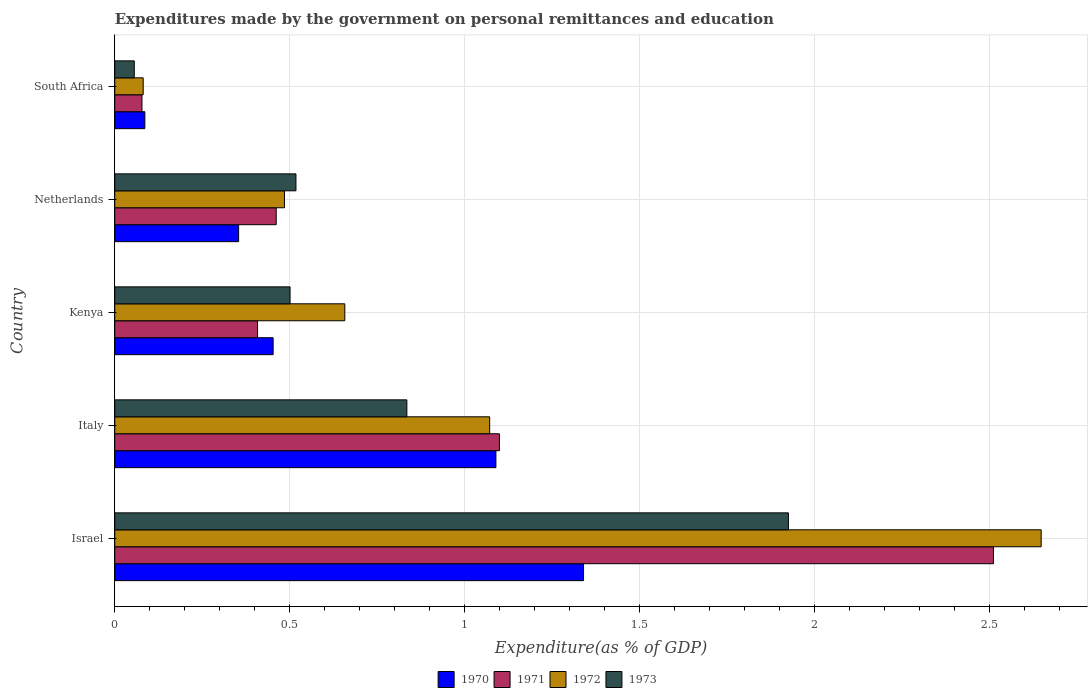How many groups of bars are there?
Your answer should be very brief. 5. Are the number of bars on each tick of the Y-axis equal?
Your answer should be very brief. Yes. How many bars are there on the 4th tick from the top?
Keep it short and to the point. 4. How many bars are there on the 4th tick from the bottom?
Your answer should be compact. 4. What is the label of the 5th group of bars from the top?
Keep it short and to the point. Israel. What is the expenditures made by the government on personal remittances and education in 1973 in Israel?
Ensure brevity in your answer.  1.93. Across all countries, what is the maximum expenditures made by the government on personal remittances and education in 1970?
Your answer should be very brief. 1.34. Across all countries, what is the minimum expenditures made by the government on personal remittances and education in 1973?
Your response must be concise. 0.06. In which country was the expenditures made by the government on personal remittances and education in 1972 minimum?
Provide a short and direct response. South Africa. What is the total expenditures made by the government on personal remittances and education in 1972 in the graph?
Ensure brevity in your answer.  4.94. What is the difference between the expenditures made by the government on personal remittances and education in 1970 in Israel and that in Netherlands?
Give a very brief answer. 0.99. What is the difference between the expenditures made by the government on personal remittances and education in 1970 in Italy and the expenditures made by the government on personal remittances and education in 1973 in Netherlands?
Provide a succinct answer. 0.57. What is the average expenditures made by the government on personal remittances and education in 1971 per country?
Give a very brief answer. 0.91. What is the difference between the expenditures made by the government on personal remittances and education in 1972 and expenditures made by the government on personal remittances and education in 1973 in Israel?
Provide a succinct answer. 0.72. In how many countries, is the expenditures made by the government on personal remittances and education in 1972 greater than 2.3 %?
Offer a very short reply. 1. What is the ratio of the expenditures made by the government on personal remittances and education in 1970 in Italy to that in Netherlands?
Give a very brief answer. 3.08. Is the difference between the expenditures made by the government on personal remittances and education in 1972 in Kenya and South Africa greater than the difference between the expenditures made by the government on personal remittances and education in 1973 in Kenya and South Africa?
Keep it short and to the point. Yes. What is the difference between the highest and the second highest expenditures made by the government on personal remittances and education in 1972?
Give a very brief answer. 1.58. What is the difference between the highest and the lowest expenditures made by the government on personal remittances and education in 1971?
Your response must be concise. 2.43. Is the sum of the expenditures made by the government on personal remittances and education in 1970 in Kenya and South Africa greater than the maximum expenditures made by the government on personal remittances and education in 1972 across all countries?
Ensure brevity in your answer.  No. Is it the case that in every country, the sum of the expenditures made by the government on personal remittances and education in 1972 and expenditures made by the government on personal remittances and education in 1973 is greater than the sum of expenditures made by the government on personal remittances and education in 1971 and expenditures made by the government on personal remittances and education in 1970?
Offer a terse response. No. What does the 3rd bar from the top in Netherlands represents?
Make the answer very short. 1971. What does the 3rd bar from the bottom in South Africa represents?
Give a very brief answer. 1972. Is it the case that in every country, the sum of the expenditures made by the government on personal remittances and education in 1971 and expenditures made by the government on personal remittances and education in 1973 is greater than the expenditures made by the government on personal remittances and education in 1970?
Offer a very short reply. Yes. What is the title of the graph?
Offer a very short reply. Expenditures made by the government on personal remittances and education. What is the label or title of the X-axis?
Provide a succinct answer. Expenditure(as % of GDP). What is the Expenditure(as % of GDP) of 1970 in Israel?
Your response must be concise. 1.34. What is the Expenditure(as % of GDP) of 1971 in Israel?
Keep it short and to the point. 2.51. What is the Expenditure(as % of GDP) of 1972 in Israel?
Provide a short and direct response. 2.65. What is the Expenditure(as % of GDP) in 1973 in Israel?
Offer a terse response. 1.93. What is the Expenditure(as % of GDP) in 1970 in Italy?
Provide a short and direct response. 1.09. What is the Expenditure(as % of GDP) of 1971 in Italy?
Offer a very short reply. 1.1. What is the Expenditure(as % of GDP) in 1972 in Italy?
Your answer should be very brief. 1.07. What is the Expenditure(as % of GDP) in 1973 in Italy?
Provide a short and direct response. 0.84. What is the Expenditure(as % of GDP) of 1970 in Kenya?
Offer a very short reply. 0.45. What is the Expenditure(as % of GDP) of 1971 in Kenya?
Provide a short and direct response. 0.41. What is the Expenditure(as % of GDP) of 1972 in Kenya?
Offer a terse response. 0.66. What is the Expenditure(as % of GDP) of 1973 in Kenya?
Offer a terse response. 0.5. What is the Expenditure(as % of GDP) of 1970 in Netherlands?
Give a very brief answer. 0.35. What is the Expenditure(as % of GDP) of 1971 in Netherlands?
Give a very brief answer. 0.46. What is the Expenditure(as % of GDP) of 1972 in Netherlands?
Offer a very short reply. 0.49. What is the Expenditure(as % of GDP) of 1973 in Netherlands?
Keep it short and to the point. 0.52. What is the Expenditure(as % of GDP) in 1970 in South Africa?
Keep it short and to the point. 0.09. What is the Expenditure(as % of GDP) in 1971 in South Africa?
Ensure brevity in your answer.  0.08. What is the Expenditure(as % of GDP) in 1972 in South Africa?
Offer a terse response. 0.08. What is the Expenditure(as % of GDP) in 1973 in South Africa?
Provide a succinct answer. 0.06. Across all countries, what is the maximum Expenditure(as % of GDP) of 1970?
Ensure brevity in your answer.  1.34. Across all countries, what is the maximum Expenditure(as % of GDP) of 1971?
Keep it short and to the point. 2.51. Across all countries, what is the maximum Expenditure(as % of GDP) in 1972?
Offer a terse response. 2.65. Across all countries, what is the maximum Expenditure(as % of GDP) of 1973?
Offer a very short reply. 1.93. Across all countries, what is the minimum Expenditure(as % of GDP) of 1970?
Offer a very short reply. 0.09. Across all countries, what is the minimum Expenditure(as % of GDP) in 1971?
Give a very brief answer. 0.08. Across all countries, what is the minimum Expenditure(as % of GDP) in 1972?
Your response must be concise. 0.08. Across all countries, what is the minimum Expenditure(as % of GDP) of 1973?
Provide a short and direct response. 0.06. What is the total Expenditure(as % of GDP) in 1970 in the graph?
Offer a very short reply. 3.32. What is the total Expenditure(as % of GDP) in 1971 in the graph?
Provide a short and direct response. 4.56. What is the total Expenditure(as % of GDP) in 1972 in the graph?
Keep it short and to the point. 4.94. What is the total Expenditure(as % of GDP) of 1973 in the graph?
Offer a very short reply. 3.84. What is the difference between the Expenditure(as % of GDP) of 1970 in Israel and that in Italy?
Your answer should be compact. 0.25. What is the difference between the Expenditure(as % of GDP) of 1971 in Israel and that in Italy?
Your response must be concise. 1.41. What is the difference between the Expenditure(as % of GDP) of 1972 in Israel and that in Italy?
Make the answer very short. 1.58. What is the difference between the Expenditure(as % of GDP) of 1973 in Israel and that in Italy?
Provide a succinct answer. 1.09. What is the difference between the Expenditure(as % of GDP) of 1970 in Israel and that in Kenya?
Your answer should be compact. 0.89. What is the difference between the Expenditure(as % of GDP) of 1971 in Israel and that in Kenya?
Provide a short and direct response. 2.1. What is the difference between the Expenditure(as % of GDP) of 1972 in Israel and that in Kenya?
Your answer should be compact. 1.99. What is the difference between the Expenditure(as % of GDP) in 1973 in Israel and that in Kenya?
Make the answer very short. 1.42. What is the difference between the Expenditure(as % of GDP) of 1970 in Israel and that in Netherlands?
Offer a terse response. 0.99. What is the difference between the Expenditure(as % of GDP) in 1971 in Israel and that in Netherlands?
Your answer should be very brief. 2.05. What is the difference between the Expenditure(as % of GDP) in 1972 in Israel and that in Netherlands?
Your answer should be very brief. 2.16. What is the difference between the Expenditure(as % of GDP) of 1973 in Israel and that in Netherlands?
Keep it short and to the point. 1.41. What is the difference between the Expenditure(as % of GDP) of 1970 in Israel and that in South Africa?
Your response must be concise. 1.25. What is the difference between the Expenditure(as % of GDP) of 1971 in Israel and that in South Africa?
Your answer should be very brief. 2.43. What is the difference between the Expenditure(as % of GDP) of 1972 in Israel and that in South Africa?
Keep it short and to the point. 2.57. What is the difference between the Expenditure(as % of GDP) in 1973 in Israel and that in South Africa?
Provide a short and direct response. 1.87. What is the difference between the Expenditure(as % of GDP) of 1970 in Italy and that in Kenya?
Keep it short and to the point. 0.64. What is the difference between the Expenditure(as % of GDP) in 1971 in Italy and that in Kenya?
Your answer should be compact. 0.69. What is the difference between the Expenditure(as % of GDP) of 1972 in Italy and that in Kenya?
Provide a short and direct response. 0.41. What is the difference between the Expenditure(as % of GDP) of 1973 in Italy and that in Kenya?
Provide a succinct answer. 0.33. What is the difference between the Expenditure(as % of GDP) of 1970 in Italy and that in Netherlands?
Offer a very short reply. 0.74. What is the difference between the Expenditure(as % of GDP) of 1971 in Italy and that in Netherlands?
Give a very brief answer. 0.64. What is the difference between the Expenditure(as % of GDP) in 1972 in Italy and that in Netherlands?
Provide a succinct answer. 0.59. What is the difference between the Expenditure(as % of GDP) in 1973 in Italy and that in Netherlands?
Your answer should be very brief. 0.32. What is the difference between the Expenditure(as % of GDP) in 1970 in Italy and that in South Africa?
Provide a short and direct response. 1. What is the difference between the Expenditure(as % of GDP) in 1971 in Italy and that in South Africa?
Make the answer very short. 1.02. What is the difference between the Expenditure(as % of GDP) of 1972 in Italy and that in South Africa?
Keep it short and to the point. 0.99. What is the difference between the Expenditure(as % of GDP) in 1973 in Italy and that in South Africa?
Keep it short and to the point. 0.78. What is the difference between the Expenditure(as % of GDP) of 1970 in Kenya and that in Netherlands?
Your answer should be compact. 0.1. What is the difference between the Expenditure(as % of GDP) in 1971 in Kenya and that in Netherlands?
Give a very brief answer. -0.05. What is the difference between the Expenditure(as % of GDP) in 1972 in Kenya and that in Netherlands?
Your answer should be compact. 0.17. What is the difference between the Expenditure(as % of GDP) in 1973 in Kenya and that in Netherlands?
Keep it short and to the point. -0.02. What is the difference between the Expenditure(as % of GDP) of 1970 in Kenya and that in South Africa?
Offer a terse response. 0.37. What is the difference between the Expenditure(as % of GDP) of 1971 in Kenya and that in South Africa?
Give a very brief answer. 0.33. What is the difference between the Expenditure(as % of GDP) of 1972 in Kenya and that in South Africa?
Offer a terse response. 0.58. What is the difference between the Expenditure(as % of GDP) of 1973 in Kenya and that in South Africa?
Provide a succinct answer. 0.45. What is the difference between the Expenditure(as % of GDP) of 1970 in Netherlands and that in South Africa?
Provide a short and direct response. 0.27. What is the difference between the Expenditure(as % of GDP) of 1971 in Netherlands and that in South Africa?
Your answer should be compact. 0.38. What is the difference between the Expenditure(as % of GDP) in 1972 in Netherlands and that in South Africa?
Ensure brevity in your answer.  0.4. What is the difference between the Expenditure(as % of GDP) of 1973 in Netherlands and that in South Africa?
Your answer should be very brief. 0.46. What is the difference between the Expenditure(as % of GDP) in 1970 in Israel and the Expenditure(as % of GDP) in 1971 in Italy?
Keep it short and to the point. 0.24. What is the difference between the Expenditure(as % of GDP) in 1970 in Israel and the Expenditure(as % of GDP) in 1972 in Italy?
Your answer should be compact. 0.27. What is the difference between the Expenditure(as % of GDP) in 1970 in Israel and the Expenditure(as % of GDP) in 1973 in Italy?
Provide a short and direct response. 0.51. What is the difference between the Expenditure(as % of GDP) in 1971 in Israel and the Expenditure(as % of GDP) in 1972 in Italy?
Offer a very short reply. 1.44. What is the difference between the Expenditure(as % of GDP) in 1971 in Israel and the Expenditure(as % of GDP) in 1973 in Italy?
Keep it short and to the point. 1.68. What is the difference between the Expenditure(as % of GDP) in 1972 in Israel and the Expenditure(as % of GDP) in 1973 in Italy?
Ensure brevity in your answer.  1.81. What is the difference between the Expenditure(as % of GDP) in 1970 in Israel and the Expenditure(as % of GDP) in 1971 in Kenya?
Provide a short and direct response. 0.93. What is the difference between the Expenditure(as % of GDP) of 1970 in Israel and the Expenditure(as % of GDP) of 1972 in Kenya?
Ensure brevity in your answer.  0.68. What is the difference between the Expenditure(as % of GDP) of 1970 in Israel and the Expenditure(as % of GDP) of 1973 in Kenya?
Give a very brief answer. 0.84. What is the difference between the Expenditure(as % of GDP) of 1971 in Israel and the Expenditure(as % of GDP) of 1972 in Kenya?
Offer a very short reply. 1.85. What is the difference between the Expenditure(as % of GDP) of 1971 in Israel and the Expenditure(as % of GDP) of 1973 in Kenya?
Provide a succinct answer. 2.01. What is the difference between the Expenditure(as % of GDP) in 1972 in Israel and the Expenditure(as % of GDP) in 1973 in Kenya?
Give a very brief answer. 2.15. What is the difference between the Expenditure(as % of GDP) in 1970 in Israel and the Expenditure(as % of GDP) in 1971 in Netherlands?
Offer a very short reply. 0.88. What is the difference between the Expenditure(as % of GDP) of 1970 in Israel and the Expenditure(as % of GDP) of 1972 in Netherlands?
Give a very brief answer. 0.85. What is the difference between the Expenditure(as % of GDP) in 1970 in Israel and the Expenditure(as % of GDP) in 1973 in Netherlands?
Your answer should be very brief. 0.82. What is the difference between the Expenditure(as % of GDP) in 1971 in Israel and the Expenditure(as % of GDP) in 1972 in Netherlands?
Provide a succinct answer. 2.03. What is the difference between the Expenditure(as % of GDP) in 1971 in Israel and the Expenditure(as % of GDP) in 1973 in Netherlands?
Provide a short and direct response. 1.99. What is the difference between the Expenditure(as % of GDP) in 1972 in Israel and the Expenditure(as % of GDP) in 1973 in Netherlands?
Give a very brief answer. 2.13. What is the difference between the Expenditure(as % of GDP) in 1970 in Israel and the Expenditure(as % of GDP) in 1971 in South Africa?
Your answer should be compact. 1.26. What is the difference between the Expenditure(as % of GDP) of 1970 in Israel and the Expenditure(as % of GDP) of 1972 in South Africa?
Offer a very short reply. 1.26. What is the difference between the Expenditure(as % of GDP) in 1970 in Israel and the Expenditure(as % of GDP) in 1973 in South Africa?
Ensure brevity in your answer.  1.28. What is the difference between the Expenditure(as % of GDP) of 1971 in Israel and the Expenditure(as % of GDP) of 1972 in South Africa?
Give a very brief answer. 2.43. What is the difference between the Expenditure(as % of GDP) in 1971 in Israel and the Expenditure(as % of GDP) in 1973 in South Africa?
Your response must be concise. 2.46. What is the difference between the Expenditure(as % of GDP) in 1972 in Israel and the Expenditure(as % of GDP) in 1973 in South Africa?
Give a very brief answer. 2.59. What is the difference between the Expenditure(as % of GDP) of 1970 in Italy and the Expenditure(as % of GDP) of 1971 in Kenya?
Your response must be concise. 0.68. What is the difference between the Expenditure(as % of GDP) in 1970 in Italy and the Expenditure(as % of GDP) in 1972 in Kenya?
Offer a very short reply. 0.43. What is the difference between the Expenditure(as % of GDP) of 1970 in Italy and the Expenditure(as % of GDP) of 1973 in Kenya?
Give a very brief answer. 0.59. What is the difference between the Expenditure(as % of GDP) in 1971 in Italy and the Expenditure(as % of GDP) in 1972 in Kenya?
Offer a terse response. 0.44. What is the difference between the Expenditure(as % of GDP) of 1971 in Italy and the Expenditure(as % of GDP) of 1973 in Kenya?
Ensure brevity in your answer.  0.6. What is the difference between the Expenditure(as % of GDP) in 1972 in Italy and the Expenditure(as % of GDP) in 1973 in Kenya?
Ensure brevity in your answer.  0.57. What is the difference between the Expenditure(as % of GDP) in 1970 in Italy and the Expenditure(as % of GDP) in 1971 in Netherlands?
Give a very brief answer. 0.63. What is the difference between the Expenditure(as % of GDP) of 1970 in Italy and the Expenditure(as % of GDP) of 1972 in Netherlands?
Offer a terse response. 0.6. What is the difference between the Expenditure(as % of GDP) of 1970 in Italy and the Expenditure(as % of GDP) of 1973 in Netherlands?
Give a very brief answer. 0.57. What is the difference between the Expenditure(as % of GDP) of 1971 in Italy and the Expenditure(as % of GDP) of 1972 in Netherlands?
Keep it short and to the point. 0.61. What is the difference between the Expenditure(as % of GDP) in 1971 in Italy and the Expenditure(as % of GDP) in 1973 in Netherlands?
Your response must be concise. 0.58. What is the difference between the Expenditure(as % of GDP) in 1972 in Italy and the Expenditure(as % of GDP) in 1973 in Netherlands?
Offer a very short reply. 0.55. What is the difference between the Expenditure(as % of GDP) of 1970 in Italy and the Expenditure(as % of GDP) of 1971 in South Africa?
Give a very brief answer. 1.01. What is the difference between the Expenditure(as % of GDP) in 1970 in Italy and the Expenditure(as % of GDP) in 1972 in South Africa?
Ensure brevity in your answer.  1.01. What is the difference between the Expenditure(as % of GDP) of 1970 in Italy and the Expenditure(as % of GDP) of 1973 in South Africa?
Make the answer very short. 1.03. What is the difference between the Expenditure(as % of GDP) of 1971 in Italy and the Expenditure(as % of GDP) of 1972 in South Africa?
Your answer should be very brief. 1.02. What is the difference between the Expenditure(as % of GDP) in 1971 in Italy and the Expenditure(as % of GDP) in 1973 in South Africa?
Keep it short and to the point. 1.04. What is the difference between the Expenditure(as % of GDP) of 1970 in Kenya and the Expenditure(as % of GDP) of 1971 in Netherlands?
Your response must be concise. -0.01. What is the difference between the Expenditure(as % of GDP) of 1970 in Kenya and the Expenditure(as % of GDP) of 1972 in Netherlands?
Provide a succinct answer. -0.03. What is the difference between the Expenditure(as % of GDP) of 1970 in Kenya and the Expenditure(as % of GDP) of 1973 in Netherlands?
Keep it short and to the point. -0.07. What is the difference between the Expenditure(as % of GDP) of 1971 in Kenya and the Expenditure(as % of GDP) of 1972 in Netherlands?
Offer a very short reply. -0.08. What is the difference between the Expenditure(as % of GDP) of 1971 in Kenya and the Expenditure(as % of GDP) of 1973 in Netherlands?
Offer a very short reply. -0.11. What is the difference between the Expenditure(as % of GDP) in 1972 in Kenya and the Expenditure(as % of GDP) in 1973 in Netherlands?
Provide a succinct answer. 0.14. What is the difference between the Expenditure(as % of GDP) of 1970 in Kenya and the Expenditure(as % of GDP) of 1972 in South Africa?
Offer a terse response. 0.37. What is the difference between the Expenditure(as % of GDP) in 1970 in Kenya and the Expenditure(as % of GDP) in 1973 in South Africa?
Provide a short and direct response. 0.4. What is the difference between the Expenditure(as % of GDP) in 1971 in Kenya and the Expenditure(as % of GDP) in 1972 in South Africa?
Ensure brevity in your answer.  0.33. What is the difference between the Expenditure(as % of GDP) of 1971 in Kenya and the Expenditure(as % of GDP) of 1973 in South Africa?
Your answer should be very brief. 0.35. What is the difference between the Expenditure(as % of GDP) of 1972 in Kenya and the Expenditure(as % of GDP) of 1973 in South Africa?
Make the answer very short. 0.6. What is the difference between the Expenditure(as % of GDP) in 1970 in Netherlands and the Expenditure(as % of GDP) in 1971 in South Africa?
Provide a short and direct response. 0.28. What is the difference between the Expenditure(as % of GDP) in 1970 in Netherlands and the Expenditure(as % of GDP) in 1972 in South Africa?
Your answer should be very brief. 0.27. What is the difference between the Expenditure(as % of GDP) of 1970 in Netherlands and the Expenditure(as % of GDP) of 1973 in South Africa?
Ensure brevity in your answer.  0.3. What is the difference between the Expenditure(as % of GDP) in 1971 in Netherlands and the Expenditure(as % of GDP) in 1972 in South Africa?
Keep it short and to the point. 0.38. What is the difference between the Expenditure(as % of GDP) in 1971 in Netherlands and the Expenditure(as % of GDP) in 1973 in South Africa?
Offer a terse response. 0.41. What is the difference between the Expenditure(as % of GDP) in 1972 in Netherlands and the Expenditure(as % of GDP) in 1973 in South Africa?
Your answer should be compact. 0.43. What is the average Expenditure(as % of GDP) in 1970 per country?
Your answer should be compact. 0.66. What is the average Expenditure(as % of GDP) in 1971 per country?
Your answer should be compact. 0.91. What is the average Expenditure(as % of GDP) in 1972 per country?
Provide a succinct answer. 0.99. What is the average Expenditure(as % of GDP) in 1973 per country?
Your answer should be compact. 0.77. What is the difference between the Expenditure(as % of GDP) of 1970 and Expenditure(as % of GDP) of 1971 in Israel?
Provide a short and direct response. -1.17. What is the difference between the Expenditure(as % of GDP) in 1970 and Expenditure(as % of GDP) in 1972 in Israel?
Ensure brevity in your answer.  -1.31. What is the difference between the Expenditure(as % of GDP) in 1970 and Expenditure(as % of GDP) in 1973 in Israel?
Provide a short and direct response. -0.59. What is the difference between the Expenditure(as % of GDP) in 1971 and Expenditure(as % of GDP) in 1972 in Israel?
Your answer should be very brief. -0.14. What is the difference between the Expenditure(as % of GDP) in 1971 and Expenditure(as % of GDP) in 1973 in Israel?
Offer a terse response. 0.59. What is the difference between the Expenditure(as % of GDP) in 1972 and Expenditure(as % of GDP) in 1973 in Israel?
Provide a succinct answer. 0.72. What is the difference between the Expenditure(as % of GDP) of 1970 and Expenditure(as % of GDP) of 1971 in Italy?
Ensure brevity in your answer.  -0.01. What is the difference between the Expenditure(as % of GDP) of 1970 and Expenditure(as % of GDP) of 1972 in Italy?
Give a very brief answer. 0.02. What is the difference between the Expenditure(as % of GDP) in 1970 and Expenditure(as % of GDP) in 1973 in Italy?
Make the answer very short. 0.25. What is the difference between the Expenditure(as % of GDP) of 1971 and Expenditure(as % of GDP) of 1972 in Italy?
Provide a succinct answer. 0.03. What is the difference between the Expenditure(as % of GDP) of 1971 and Expenditure(as % of GDP) of 1973 in Italy?
Provide a short and direct response. 0.26. What is the difference between the Expenditure(as % of GDP) in 1972 and Expenditure(as % of GDP) in 1973 in Italy?
Offer a very short reply. 0.24. What is the difference between the Expenditure(as % of GDP) of 1970 and Expenditure(as % of GDP) of 1971 in Kenya?
Give a very brief answer. 0.04. What is the difference between the Expenditure(as % of GDP) of 1970 and Expenditure(as % of GDP) of 1972 in Kenya?
Provide a short and direct response. -0.2. What is the difference between the Expenditure(as % of GDP) of 1970 and Expenditure(as % of GDP) of 1973 in Kenya?
Your answer should be compact. -0.05. What is the difference between the Expenditure(as % of GDP) of 1971 and Expenditure(as % of GDP) of 1972 in Kenya?
Your answer should be compact. -0.25. What is the difference between the Expenditure(as % of GDP) in 1971 and Expenditure(as % of GDP) in 1973 in Kenya?
Give a very brief answer. -0.09. What is the difference between the Expenditure(as % of GDP) of 1972 and Expenditure(as % of GDP) of 1973 in Kenya?
Provide a succinct answer. 0.16. What is the difference between the Expenditure(as % of GDP) in 1970 and Expenditure(as % of GDP) in 1971 in Netherlands?
Provide a short and direct response. -0.11. What is the difference between the Expenditure(as % of GDP) in 1970 and Expenditure(as % of GDP) in 1972 in Netherlands?
Offer a very short reply. -0.13. What is the difference between the Expenditure(as % of GDP) of 1970 and Expenditure(as % of GDP) of 1973 in Netherlands?
Your response must be concise. -0.16. What is the difference between the Expenditure(as % of GDP) in 1971 and Expenditure(as % of GDP) in 1972 in Netherlands?
Your answer should be very brief. -0.02. What is the difference between the Expenditure(as % of GDP) in 1971 and Expenditure(as % of GDP) in 1973 in Netherlands?
Ensure brevity in your answer.  -0.06. What is the difference between the Expenditure(as % of GDP) in 1972 and Expenditure(as % of GDP) in 1973 in Netherlands?
Make the answer very short. -0.03. What is the difference between the Expenditure(as % of GDP) in 1970 and Expenditure(as % of GDP) in 1971 in South Africa?
Ensure brevity in your answer.  0.01. What is the difference between the Expenditure(as % of GDP) of 1970 and Expenditure(as % of GDP) of 1972 in South Africa?
Provide a short and direct response. 0. What is the difference between the Expenditure(as % of GDP) of 1970 and Expenditure(as % of GDP) of 1973 in South Africa?
Provide a succinct answer. 0.03. What is the difference between the Expenditure(as % of GDP) of 1971 and Expenditure(as % of GDP) of 1972 in South Africa?
Your response must be concise. -0. What is the difference between the Expenditure(as % of GDP) in 1971 and Expenditure(as % of GDP) in 1973 in South Africa?
Offer a very short reply. 0.02. What is the difference between the Expenditure(as % of GDP) in 1972 and Expenditure(as % of GDP) in 1973 in South Africa?
Provide a succinct answer. 0.03. What is the ratio of the Expenditure(as % of GDP) in 1970 in Israel to that in Italy?
Provide a short and direct response. 1.23. What is the ratio of the Expenditure(as % of GDP) of 1971 in Israel to that in Italy?
Your answer should be very brief. 2.28. What is the ratio of the Expenditure(as % of GDP) in 1972 in Israel to that in Italy?
Offer a very short reply. 2.47. What is the ratio of the Expenditure(as % of GDP) of 1973 in Israel to that in Italy?
Give a very brief answer. 2.31. What is the ratio of the Expenditure(as % of GDP) in 1970 in Israel to that in Kenya?
Your response must be concise. 2.96. What is the ratio of the Expenditure(as % of GDP) in 1971 in Israel to that in Kenya?
Your answer should be very brief. 6.15. What is the ratio of the Expenditure(as % of GDP) in 1972 in Israel to that in Kenya?
Keep it short and to the point. 4.03. What is the ratio of the Expenditure(as % of GDP) of 1973 in Israel to that in Kenya?
Your response must be concise. 3.84. What is the ratio of the Expenditure(as % of GDP) of 1970 in Israel to that in Netherlands?
Give a very brief answer. 3.78. What is the ratio of the Expenditure(as % of GDP) of 1971 in Israel to that in Netherlands?
Ensure brevity in your answer.  5.44. What is the ratio of the Expenditure(as % of GDP) of 1972 in Israel to that in Netherlands?
Provide a short and direct response. 5.46. What is the ratio of the Expenditure(as % of GDP) in 1973 in Israel to that in Netherlands?
Keep it short and to the point. 3.72. What is the ratio of the Expenditure(as % of GDP) in 1970 in Israel to that in South Africa?
Keep it short and to the point. 15.58. What is the ratio of the Expenditure(as % of GDP) in 1971 in Israel to that in South Africa?
Ensure brevity in your answer.  32.29. What is the ratio of the Expenditure(as % of GDP) of 1972 in Israel to that in South Africa?
Provide a short and direct response. 32.58. What is the ratio of the Expenditure(as % of GDP) in 1973 in Israel to that in South Africa?
Provide a short and direct response. 34.5. What is the ratio of the Expenditure(as % of GDP) in 1970 in Italy to that in Kenya?
Your response must be concise. 2.41. What is the ratio of the Expenditure(as % of GDP) in 1971 in Italy to that in Kenya?
Keep it short and to the point. 2.69. What is the ratio of the Expenditure(as % of GDP) of 1972 in Italy to that in Kenya?
Give a very brief answer. 1.63. What is the ratio of the Expenditure(as % of GDP) of 1973 in Italy to that in Kenya?
Your answer should be compact. 1.67. What is the ratio of the Expenditure(as % of GDP) in 1970 in Italy to that in Netherlands?
Provide a succinct answer. 3.08. What is the ratio of the Expenditure(as % of GDP) of 1971 in Italy to that in Netherlands?
Provide a succinct answer. 2.38. What is the ratio of the Expenditure(as % of GDP) of 1972 in Italy to that in Netherlands?
Your answer should be compact. 2.21. What is the ratio of the Expenditure(as % of GDP) of 1973 in Italy to that in Netherlands?
Your answer should be very brief. 1.61. What is the ratio of the Expenditure(as % of GDP) of 1970 in Italy to that in South Africa?
Provide a short and direct response. 12.67. What is the ratio of the Expenditure(as % of GDP) of 1971 in Italy to that in South Africa?
Keep it short and to the point. 14.13. What is the ratio of the Expenditure(as % of GDP) of 1972 in Italy to that in South Africa?
Your answer should be very brief. 13.18. What is the ratio of the Expenditure(as % of GDP) of 1973 in Italy to that in South Africa?
Offer a terse response. 14.96. What is the ratio of the Expenditure(as % of GDP) in 1970 in Kenya to that in Netherlands?
Provide a short and direct response. 1.28. What is the ratio of the Expenditure(as % of GDP) of 1971 in Kenya to that in Netherlands?
Provide a short and direct response. 0.88. What is the ratio of the Expenditure(as % of GDP) in 1972 in Kenya to that in Netherlands?
Your answer should be compact. 1.36. What is the ratio of the Expenditure(as % of GDP) in 1973 in Kenya to that in Netherlands?
Provide a short and direct response. 0.97. What is the ratio of the Expenditure(as % of GDP) in 1970 in Kenya to that in South Africa?
Your answer should be very brief. 5.26. What is the ratio of the Expenditure(as % of GDP) in 1971 in Kenya to that in South Africa?
Offer a very short reply. 5.25. What is the ratio of the Expenditure(as % of GDP) in 1972 in Kenya to that in South Africa?
Your answer should be compact. 8.09. What is the ratio of the Expenditure(as % of GDP) in 1973 in Kenya to that in South Africa?
Your answer should be compact. 8.98. What is the ratio of the Expenditure(as % of GDP) in 1970 in Netherlands to that in South Africa?
Provide a succinct answer. 4.12. What is the ratio of the Expenditure(as % of GDP) in 1971 in Netherlands to that in South Africa?
Your answer should be very brief. 5.93. What is the ratio of the Expenditure(as % of GDP) of 1972 in Netherlands to that in South Africa?
Offer a very short reply. 5.97. What is the ratio of the Expenditure(as % of GDP) of 1973 in Netherlands to that in South Africa?
Your answer should be compact. 9.28. What is the difference between the highest and the second highest Expenditure(as % of GDP) of 1970?
Your response must be concise. 0.25. What is the difference between the highest and the second highest Expenditure(as % of GDP) in 1971?
Provide a short and direct response. 1.41. What is the difference between the highest and the second highest Expenditure(as % of GDP) in 1972?
Your response must be concise. 1.58. What is the difference between the highest and the second highest Expenditure(as % of GDP) of 1973?
Offer a terse response. 1.09. What is the difference between the highest and the lowest Expenditure(as % of GDP) of 1970?
Your answer should be very brief. 1.25. What is the difference between the highest and the lowest Expenditure(as % of GDP) in 1971?
Provide a succinct answer. 2.43. What is the difference between the highest and the lowest Expenditure(as % of GDP) in 1972?
Keep it short and to the point. 2.57. What is the difference between the highest and the lowest Expenditure(as % of GDP) of 1973?
Ensure brevity in your answer.  1.87. 